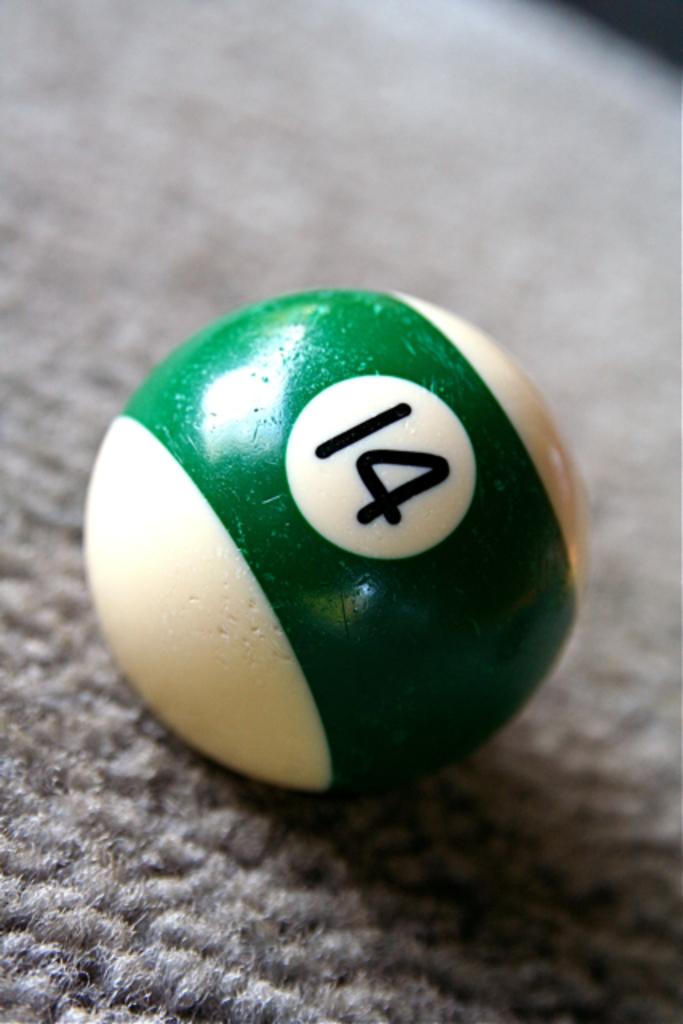What number is on the pool ball?
Your response must be concise. 14. What number ball is this?
Your answer should be very brief. 14. 